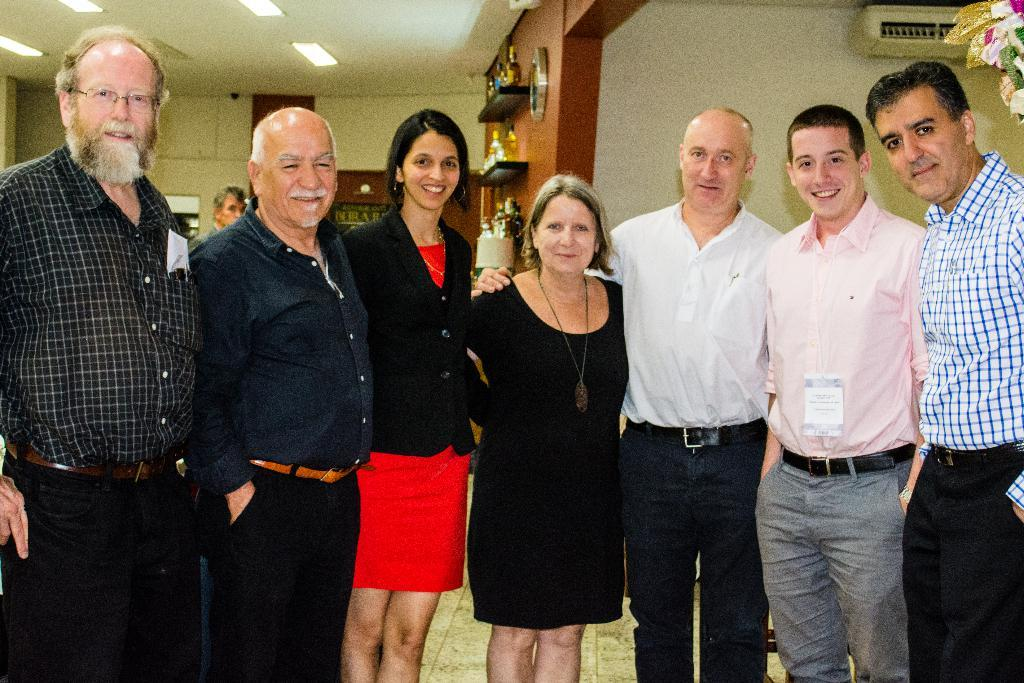What can be seen in the image involving people? There are people standing in the image. How can the people be distinguished from one another? The people are wearing different color dresses. What is a feature of the background in the image? There is a wall in the image. What type of illumination is present in the image? There are lights in the image. What can be found on the shelves in the image? There are objects on shelves in the image. What type of quince is being sorted by hand in the image? There is no quince or sorting activity involving hands present in the image. 